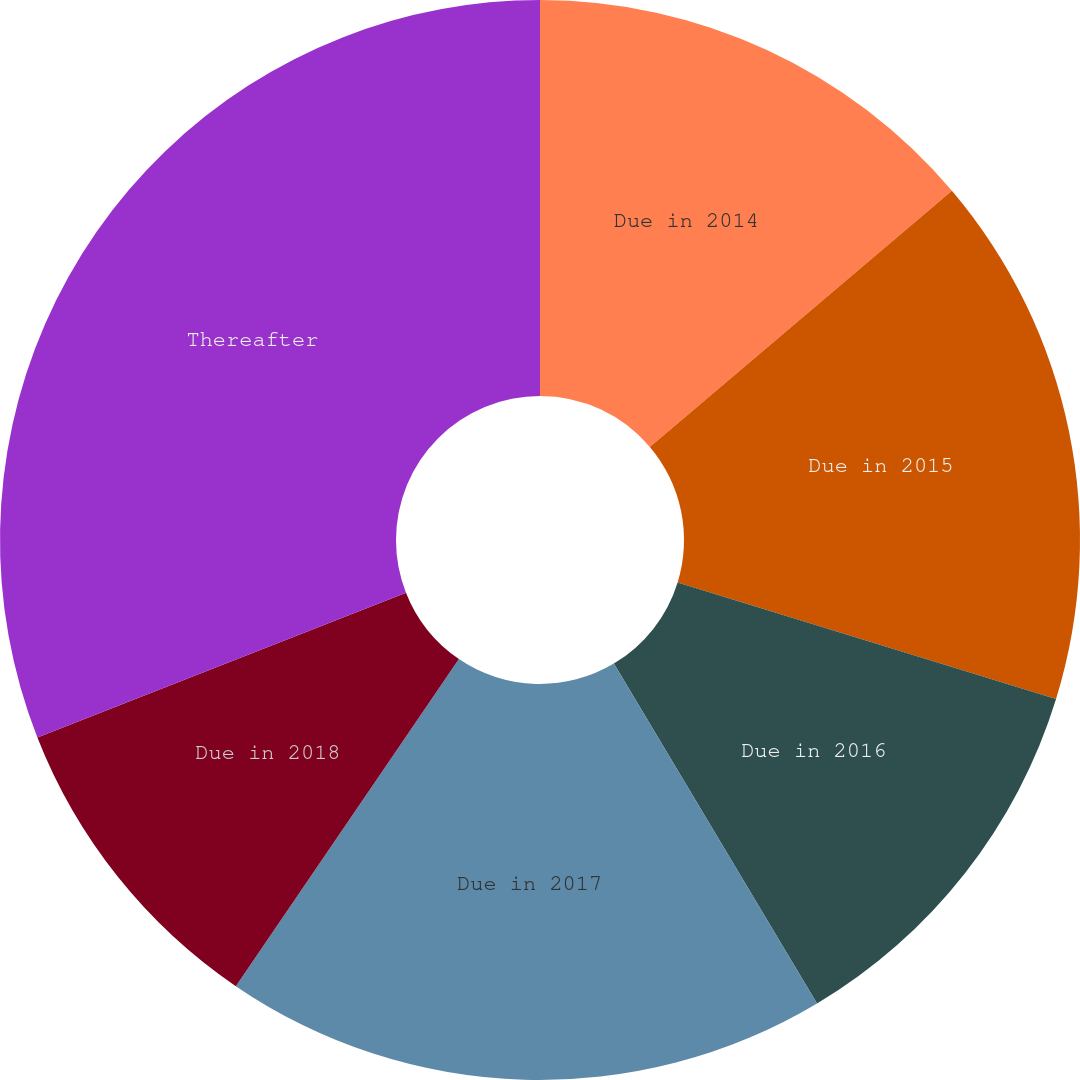<chart> <loc_0><loc_0><loc_500><loc_500><pie_chart><fcel>Due in 2014<fcel>Due in 2015<fcel>Due in 2016<fcel>Due in 2017<fcel>Due in 2018<fcel>Thereafter<nl><fcel>13.81%<fcel>15.95%<fcel>11.67%<fcel>18.1%<fcel>9.52%<fcel>30.96%<nl></chart> 